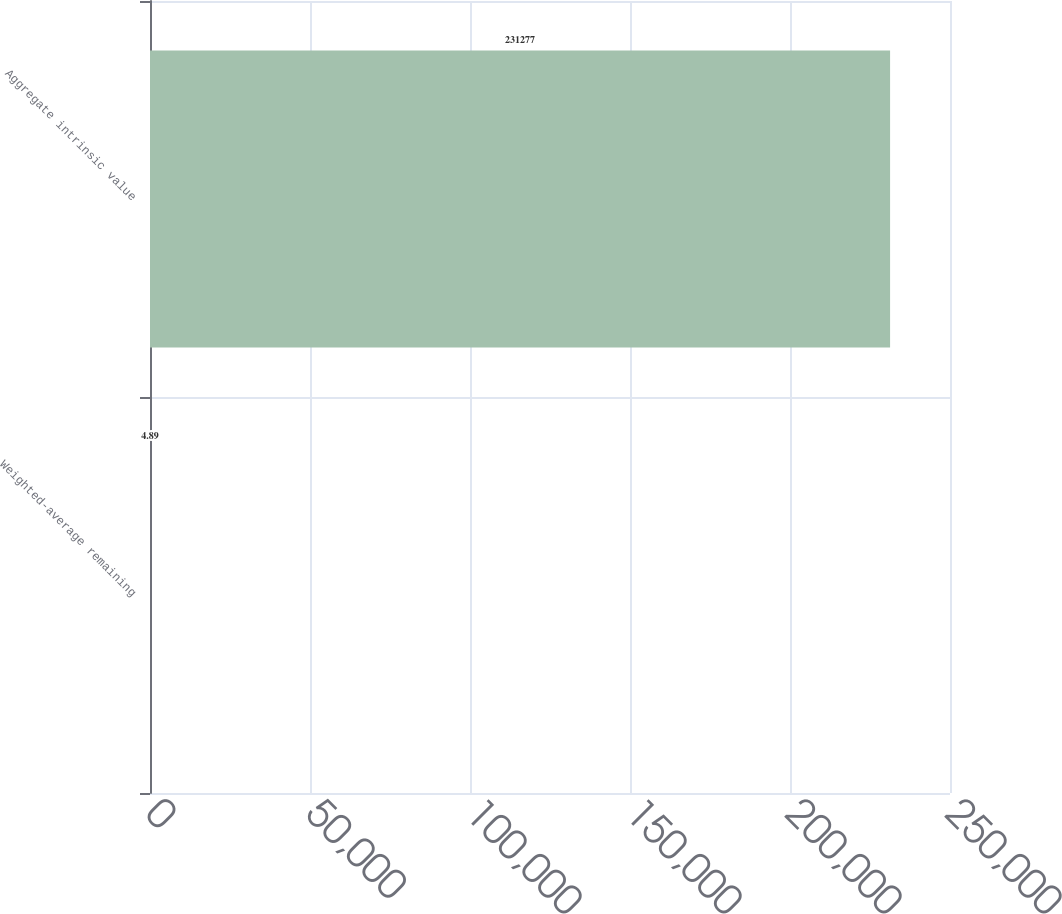Convert chart to OTSL. <chart><loc_0><loc_0><loc_500><loc_500><bar_chart><fcel>Weighted-average remaining<fcel>Aggregate intrinsic value<nl><fcel>4.89<fcel>231277<nl></chart> 